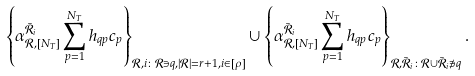Convert formula to latex. <formula><loc_0><loc_0><loc_500><loc_500>& \left \{ \alpha _ { { \mathcal { R } } , { [ N _ { T } ] } } ^ { \bar { \mathcal { R } } _ { i } } \sum _ { p = 1 } ^ { N _ { T } } h _ { q p } c _ { p } \right \} _ { \mathcal { R } , i \colon \mathcal { R } \ni q , | \mathcal { R } | = r + 1 , i \in [ \rho ] } \cup \left \{ \alpha _ { { \mathcal { R } } , { [ N _ { T } ] } } ^ { \bar { \mathcal { R } } _ { i } } \sum _ { p = 1 } ^ { N _ { T } } h _ { q p } c _ { p } \right \} _ { \mathcal { R } , \bar { \mathcal { R } } _ { i } \colon \mathcal { R } \cup \bar { \mathcal { R } } _ { i } \not \ni q } .</formula> 